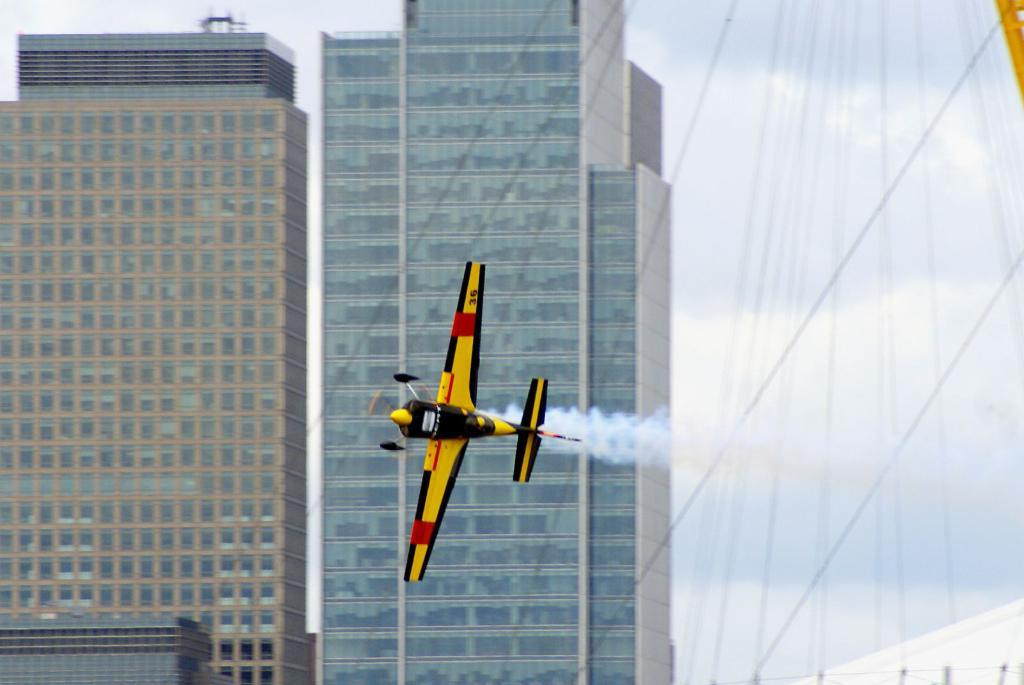What is the main subject of the image? The main subject of the image is an airplane flying. What can be seen in the background of the image? There are buildings and the sky visible in the background of the image. What type of thread is being used to hold the jail in the image? There is no jail present in the image, so there is no thread being used to hold it. 